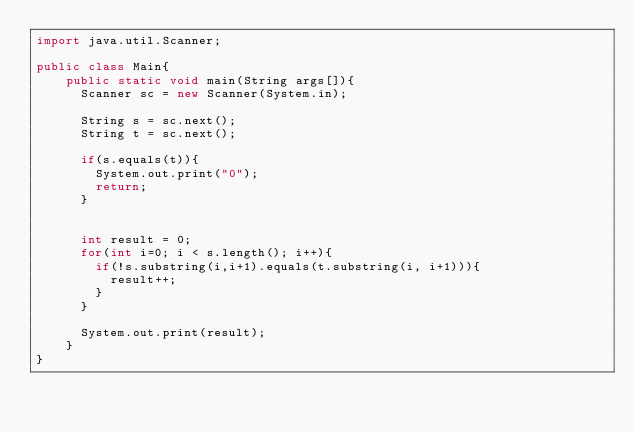Convert code to text. <code><loc_0><loc_0><loc_500><loc_500><_Java_>import java.util.Scanner;

public class Main{
	public static void main(String args[]){
      Scanner sc = new Scanner(System.in);
      
      String s = sc.next();
      String t = sc.next();
      
      if(s.equals(t)){
        System.out.print("0");
        return;
      }
        
      
      int result = 0;
      for(int i=0; i < s.length(); i++){
      	if(!s.substring(i,i+1).equals(t.substring(i, i+1))){
          result++;
        }
      }
        
      System.out.print(result);
    }
}
</code> 